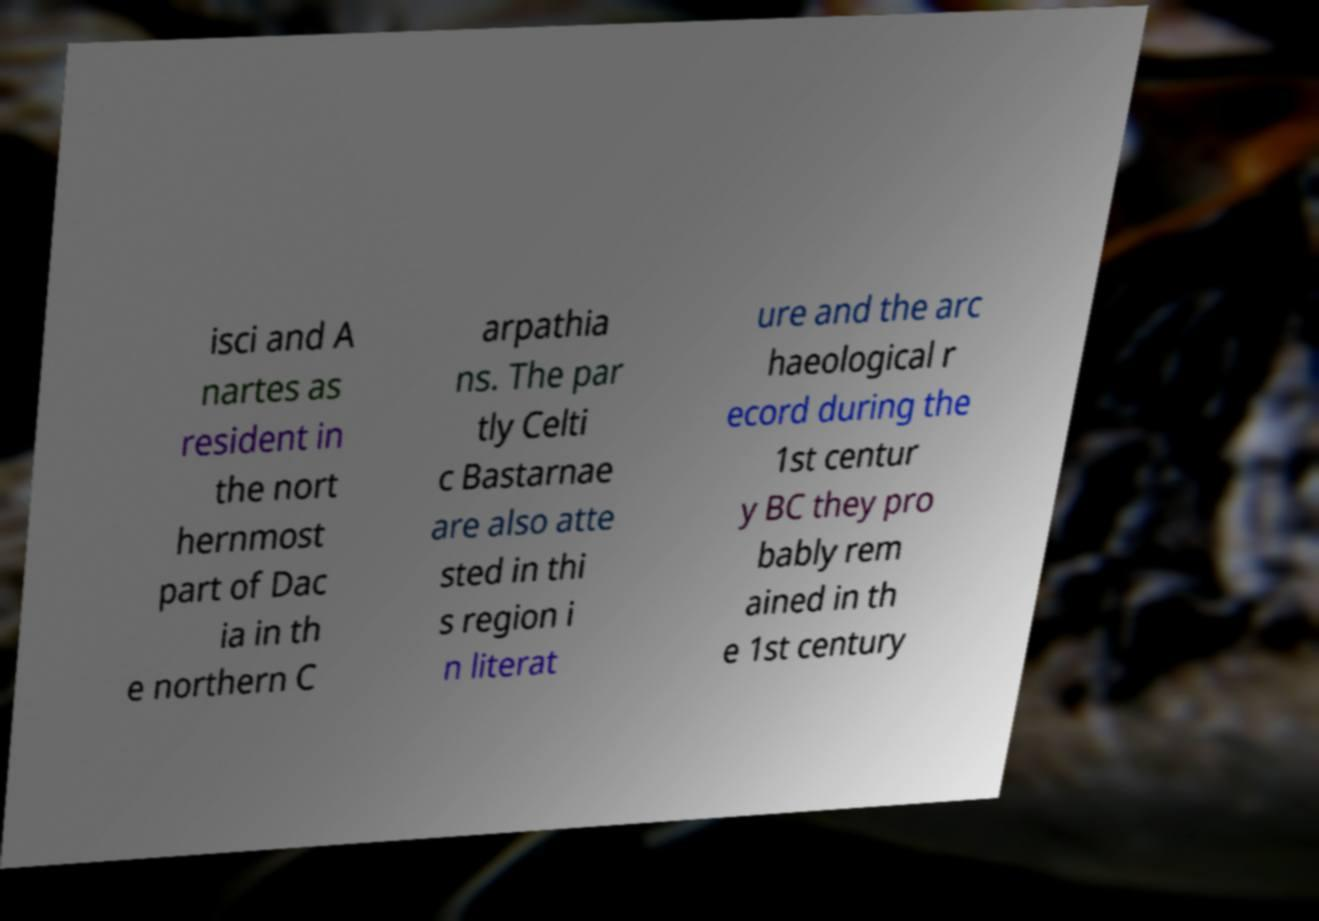Can you read and provide the text displayed in the image?This photo seems to have some interesting text. Can you extract and type it out for me? isci and A nartes as resident in the nort hernmost part of Dac ia in th e northern C arpathia ns. The par tly Celti c Bastarnae are also atte sted in thi s region i n literat ure and the arc haeological r ecord during the 1st centur y BC they pro bably rem ained in th e 1st century 